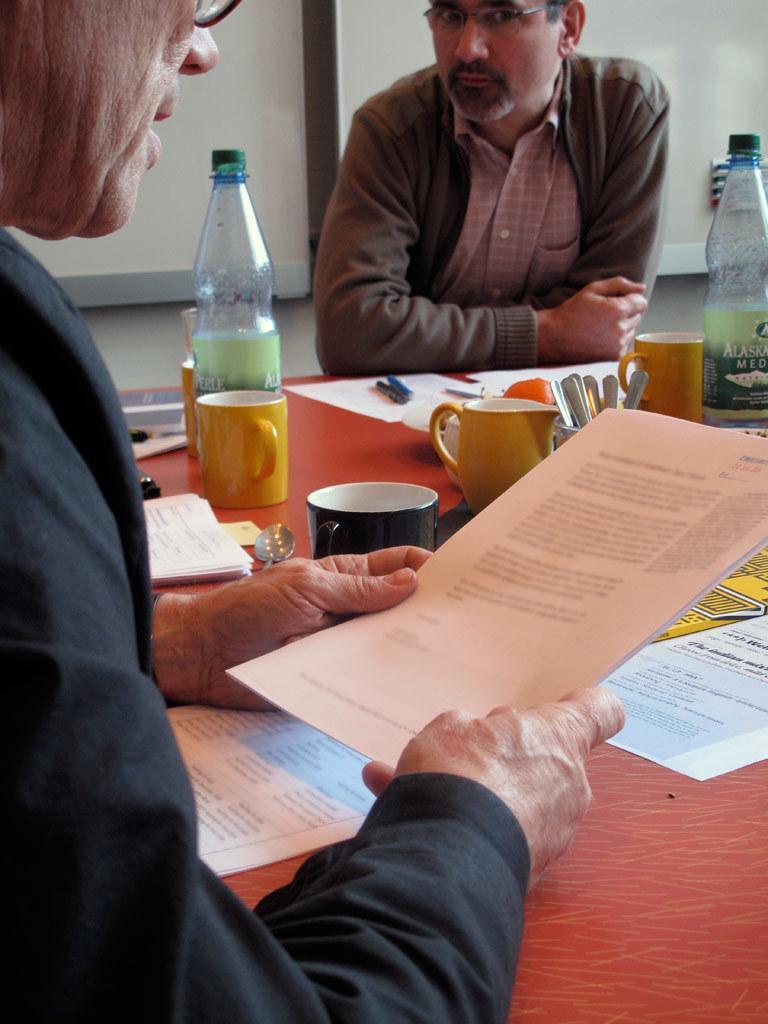Can you describe this image briefly? In this image, we can see orange color table, papers, cup, spoon, bottle with liquid, pens and holder. In the middle, a human is seeing. And he wear specs. And the left side, another human is seeing. He hold papers. 